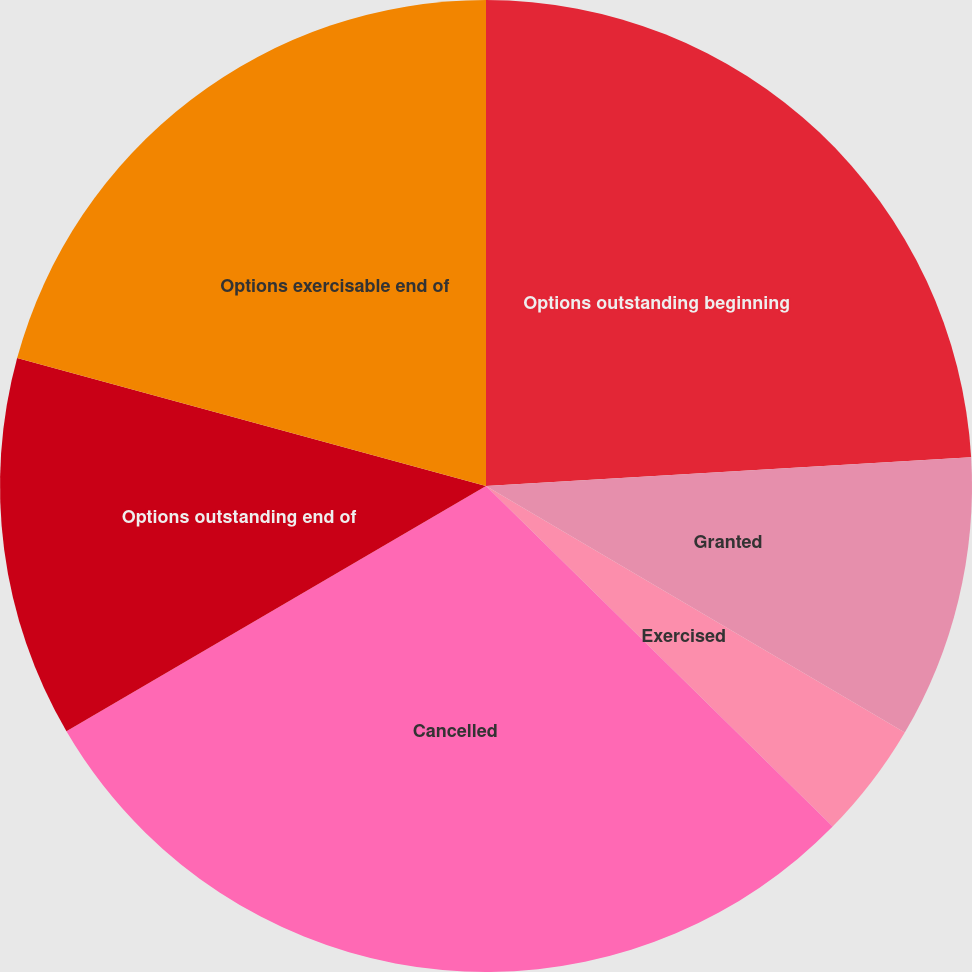Convert chart to OTSL. <chart><loc_0><loc_0><loc_500><loc_500><pie_chart><fcel>Options outstanding beginning<fcel>Granted<fcel>Exercised<fcel>Cancelled<fcel>Options outstanding end of<fcel>Options exercisable end of<nl><fcel>24.06%<fcel>9.41%<fcel>3.89%<fcel>29.22%<fcel>12.66%<fcel>20.76%<nl></chart> 